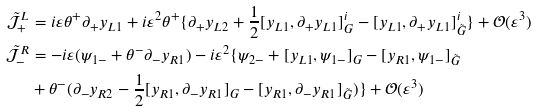Convert formula to latex. <formula><loc_0><loc_0><loc_500><loc_500>\mathcal { \tilde { J } } _ { + } ^ { L } & = i \varepsilon \theta ^ { + } \partial _ { + } y _ { L 1 } + i \varepsilon ^ { 2 } \theta ^ { + } \{ \partial _ { + } y _ { L 2 } + \frac { 1 } { 2 } [ y _ { L 1 } , \partial _ { + } y _ { L 1 } ] _ { G } ^ { i } - [ y _ { L 1 } , \partial _ { + } y _ { L 1 } ] _ { \tilde { G } } ^ { i } \} + \mathcal { O } ( \varepsilon ^ { 3 } ) \\ \mathcal { \tilde { J } } _ { - } ^ { R } & = - i \varepsilon ( \psi _ { 1 - } + \theta ^ { - } \partial _ { - } y _ { R 1 } ) - i \varepsilon ^ { 2 } \{ \psi _ { 2 - } + [ y _ { L 1 } , \psi _ { 1 - } ] _ { G } - [ y _ { R 1 } , \psi _ { 1 - } ] _ { \tilde { G } } \\ & + \theta ^ { - } ( \partial _ { - } y _ { R 2 } - \frac { 1 } { 2 } [ y _ { R 1 } , \partial _ { - } y _ { R 1 } ] _ { G } - [ y _ { R 1 } , \partial _ { - } y _ { R 1 } ] _ { \tilde { G } } ) \} + \mathcal { O } ( \varepsilon ^ { 3 } )</formula> 